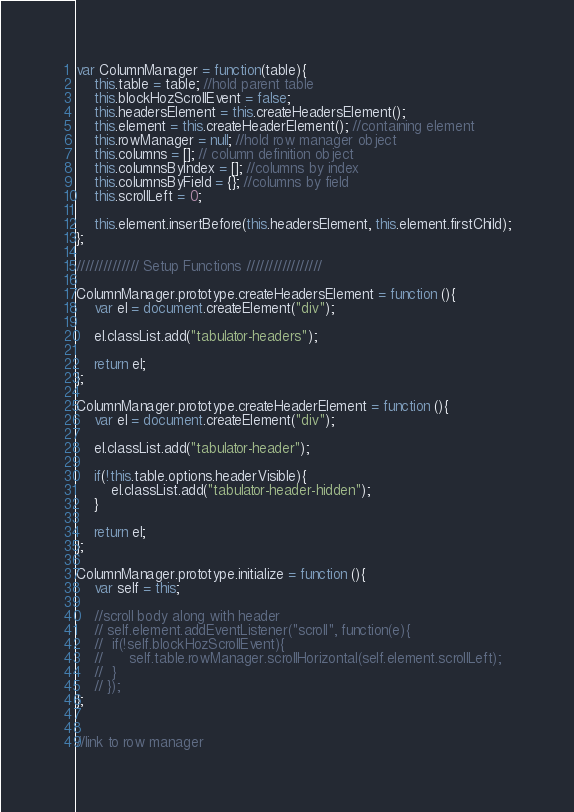Convert code to text. <code><loc_0><loc_0><loc_500><loc_500><_JavaScript_>var ColumnManager = function(table){
	this.table = table; //hold parent table
	this.blockHozScrollEvent = false;
	this.headersElement = this.createHeadersElement();
	this.element = this.createHeaderElement(); //containing element
	this.rowManager = null; //hold row manager object
	this.columns = []; // column definition object
	this.columnsByIndex = []; //columns by index
	this.columnsByField = {}; //columns by field
	this.scrollLeft = 0;

	this.element.insertBefore(this.headersElement, this.element.firstChild);
};

////////////// Setup Functions /////////////////

ColumnManager.prototype.createHeadersElement = function (){
	var el = document.createElement("div");

	el.classList.add("tabulator-headers");

	return el;
};

ColumnManager.prototype.createHeaderElement = function (){
	var el = document.createElement("div");

	el.classList.add("tabulator-header");

	if(!this.table.options.headerVisible){
		el.classList.add("tabulator-header-hidden");
	}

	return el;
};

ColumnManager.prototype.initialize = function (){
	var self = this;

	//scroll body along with header
	// self.element.addEventListener("scroll", function(e){
	// 	if(!self.blockHozScrollEvent){
	// 		self.table.rowManager.scrollHorizontal(self.element.scrollLeft);
	// 	}
	// });
};


//link to row manager</code> 